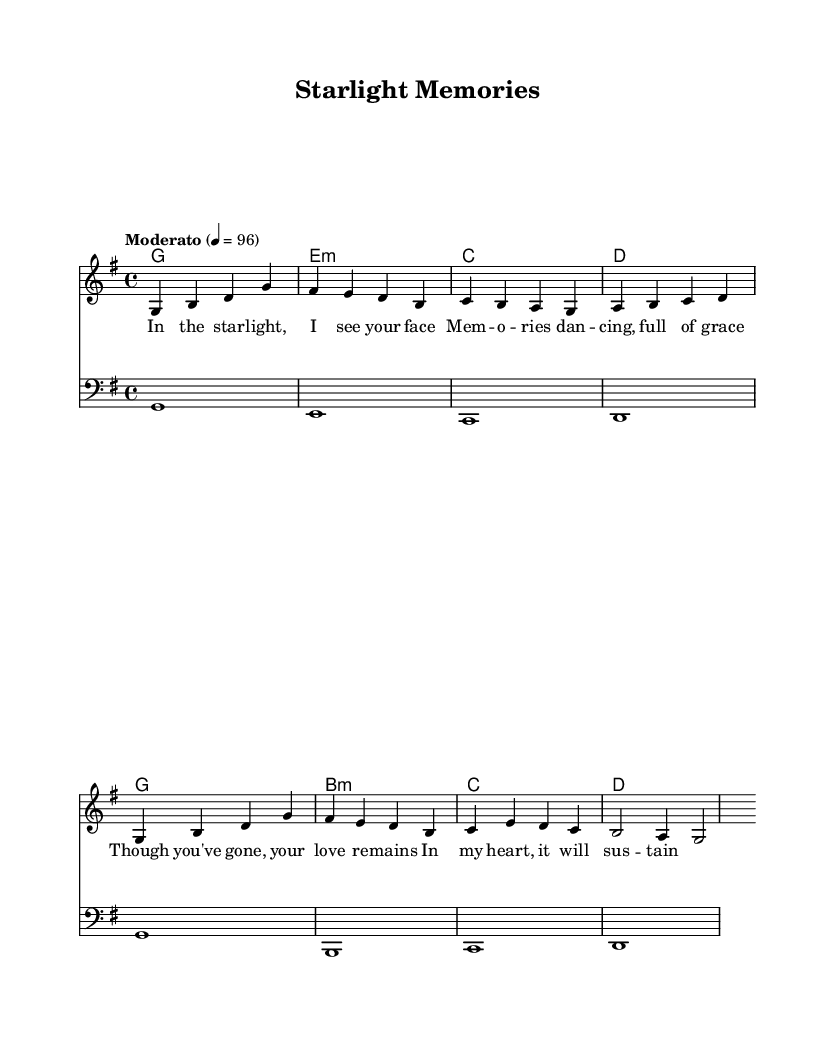What is the key signature of this music? The key signature of this piece is G major, which has one sharp (F#). This can be determined by looking at the key signature shown at the beginning of the staff, indicating the raised seventh note in the scale.
Answer: G major What is the time signature of this music? The time signature is 4/4, as shown at the beginning of the score. This indicates that there are four beats in each measure, with a quarter note receiving one beat.
Answer: 4/4 What is the tempo marking for this music? The tempo marking is "Moderato," which generally indicates a moderately paced performance. This marking can be found at the beginning of the score along with the specific metronome mark of 96 beats per minute.
Answer: Moderato How many measures are there in the melody? The melody consists of eight measures, as can be observed by counting the groups of notes separated by vertical lines in the sheet music. Each group represents a measure.
Answer: Eight What is the first chord of the harmony? The first chord in the harmony section is G major, which is denoted as 'g1'. This chord is the first symbol seen in the chord section, indicating the root note and the chord type.
Answer: G major In which lyrical phrase does the word "memories" appear? The word "memories" appears in the second line of the lyrics. This can be identified by reading through the text aligned with the melody notes and locating the specific word in the context of the music.
Answer: Second line What musical element is being celebrated in this song? The song celebrates the memory of a departed loved one, as indicated by the lyrics that reflect themes of remembrance and love persisting despite loss. This sentiment can be inferred from the overall message conveyed in the text associated with the melody.
Answer: Memory 